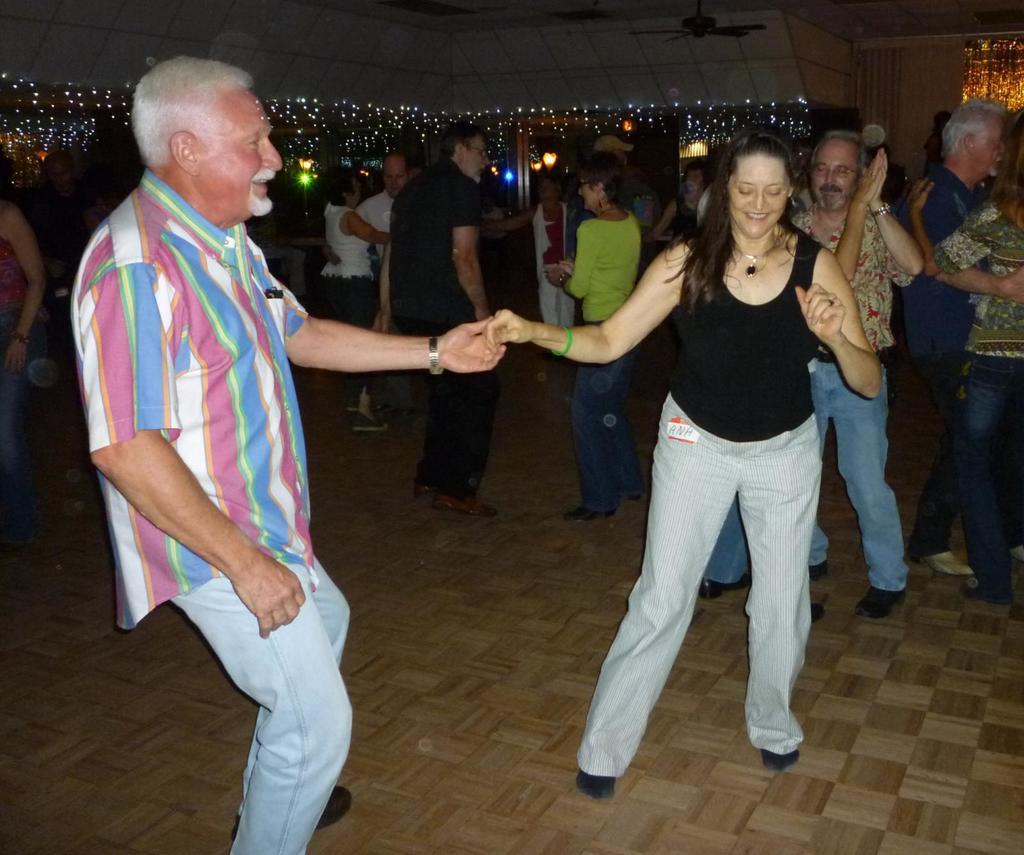Can you describe this image briefly? In this image in the front there are persons dancing and smiling. In the background there are persons standing and dancing and there are lights and there are fans and there is a wall on the right side. 